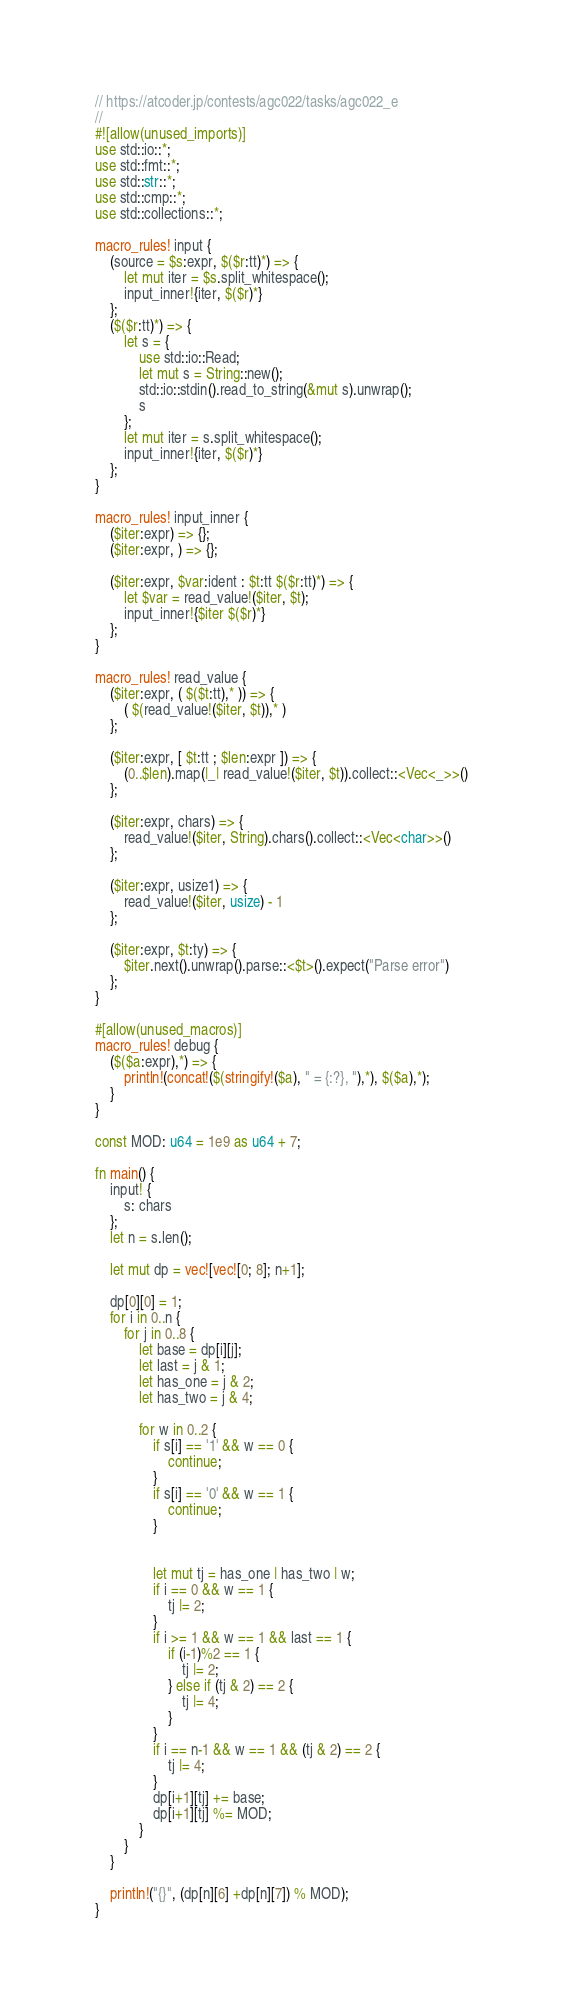Convert code to text. <code><loc_0><loc_0><loc_500><loc_500><_Rust_>// https://atcoder.jp/contests/agc022/tasks/agc022_e
//
#![allow(unused_imports)]
use std::io::*;
use std::fmt::*;
use std::str::*;
use std::cmp::*;
use std::collections::*;

macro_rules! input {
    (source = $s:expr, $($r:tt)*) => {
        let mut iter = $s.split_whitespace();
        input_inner!{iter, $($r)*}
    };
    ($($r:tt)*) => {
        let s = {
            use std::io::Read;
            let mut s = String::new();
            std::io::stdin().read_to_string(&mut s).unwrap();
            s
        };
        let mut iter = s.split_whitespace();
        input_inner!{iter, $($r)*}
    };
}

macro_rules! input_inner {
    ($iter:expr) => {};
    ($iter:expr, ) => {};

    ($iter:expr, $var:ident : $t:tt $($r:tt)*) => {
        let $var = read_value!($iter, $t);
        input_inner!{$iter $($r)*}
    };
}

macro_rules! read_value {
    ($iter:expr, ( $($t:tt),* )) => {
        ( $(read_value!($iter, $t)),* )
    };

    ($iter:expr, [ $t:tt ; $len:expr ]) => {
        (0..$len).map(|_| read_value!($iter, $t)).collect::<Vec<_>>()
    };

    ($iter:expr, chars) => {
        read_value!($iter, String).chars().collect::<Vec<char>>()
    };

    ($iter:expr, usize1) => {
        read_value!($iter, usize) - 1
    };

    ($iter:expr, $t:ty) => {
        $iter.next().unwrap().parse::<$t>().expect("Parse error")
    };
}

#[allow(unused_macros)]
macro_rules! debug {
    ($($a:expr),*) => {
        println!(concat!($(stringify!($a), " = {:?}, "),*), $($a),*);
    }
}

const MOD: u64 = 1e9 as u64 + 7;

fn main() {
    input! {
        s: chars
    };
    let n = s.len();

    let mut dp = vec![vec![0; 8]; n+1];

    dp[0][0] = 1;
    for i in 0..n {
        for j in 0..8 {
            let base = dp[i][j];
            let last = j & 1;
            let has_one = j & 2;
            let has_two = j & 4;

            for w in 0..2 {
                if s[i] == '1' && w == 0 {
                    continue;
                }
                if s[i] == '0' && w == 1 {
                    continue;
                }


                let mut tj = has_one | has_two | w;
                if i == 0 && w == 1 {
                    tj |= 2;
                }
                if i >= 1 && w == 1 && last == 1 {
                    if (i-1)%2 == 1 {
                        tj |= 2;
                    } else if (tj & 2) == 2 {
                        tj |= 4;
                    }
                }
                if i == n-1 && w == 1 && (tj & 2) == 2 {
                    tj |= 4;
                }
                dp[i+1][tj] += base;
                dp[i+1][tj] %= MOD;
            }
        }
    }

    println!("{}", (dp[n][6] +dp[n][7]) % MOD);
}
</code> 